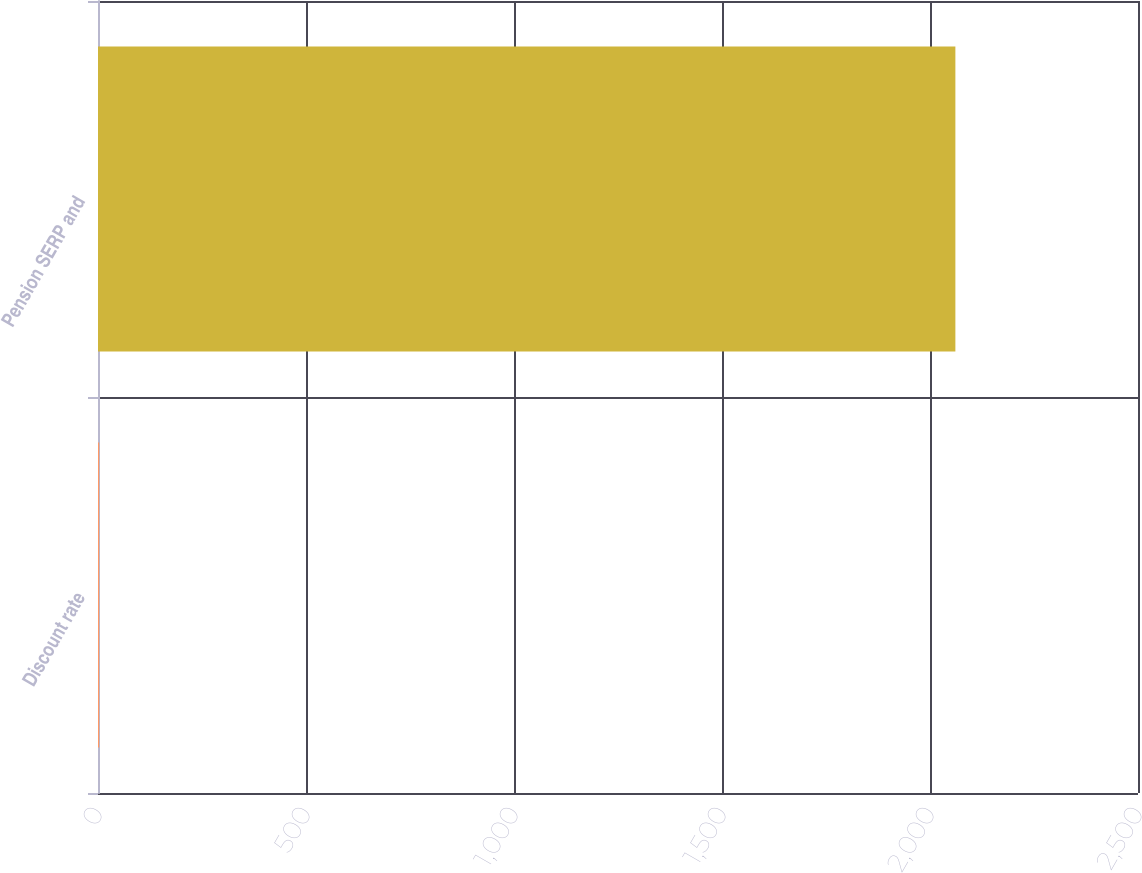Convert chart. <chart><loc_0><loc_0><loc_500><loc_500><bar_chart><fcel>Discount rate<fcel>Pension SERP and<nl><fcel>2.75<fcel>2061<nl></chart> 